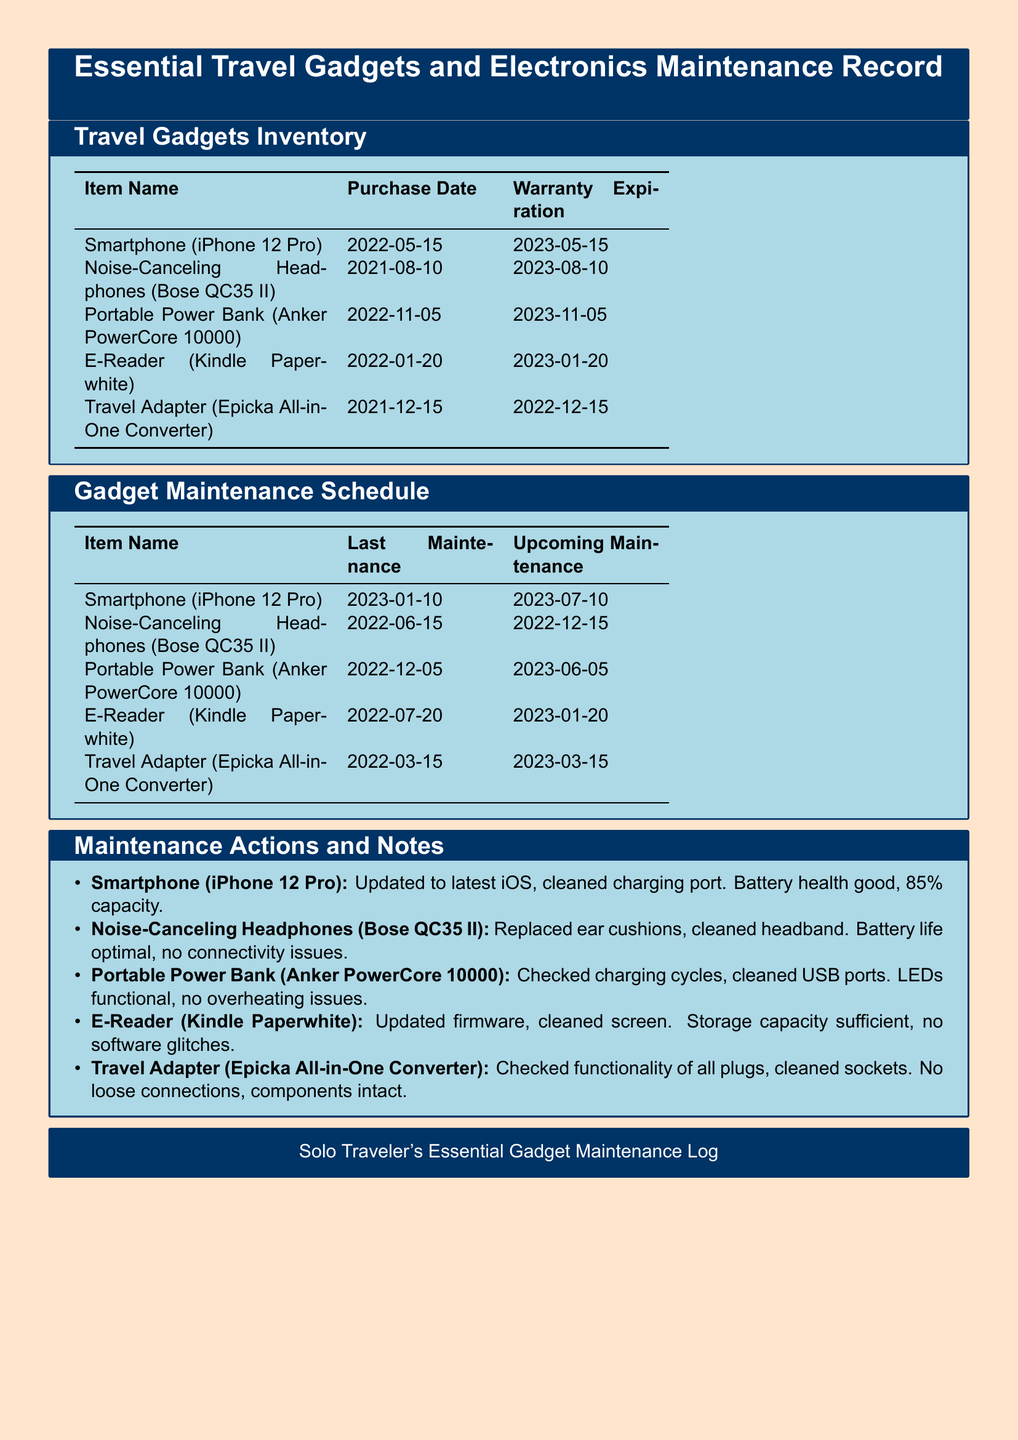What is the purchase date of the Portable Power Bank? The purchase date is listed in the inventory table under the Portable Power Bank row.
Answer: 2022-11-05 What item has the longest warranty period remaining? By comparing the warranty expiration dates of all items, we find the one furthest in the future.
Answer: Portable Power Bank (Anker PowerCore 10000) When was the last maintenance performed on the E-Reader? The last maintenance date can be found in the maintenance schedule under the E-Reader row.
Answer: 2022-07-20 What maintenance action was taken for the Noise-Canceling Headphones? The maintenance actions are listed under their respective item and include specific tasks done.
Answer: Replaced ear cushions, cleaned headband How many items have a warranty expiration date in 2023? We count the number of items listed in the inventory table with a warranty expiration in 2023.
Answer: 4 